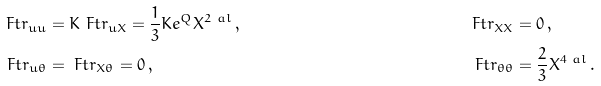<formula> <loc_0><loc_0><loc_500><loc_500>\ F t r _ { u u } & = K \ F t r _ { u X } = \frac { 1 } { 3 } K e ^ { Q } X ^ { 2 \ a l } \, , & \ F t r _ { X X } & = 0 \, , \\ \ F t r _ { u \theta } & = \ F t r _ { X \theta } = 0 \, , & \ F t r _ { \theta \theta } & = \frac { 2 } { 3 } X ^ { 4 \ a l } \, .</formula> 